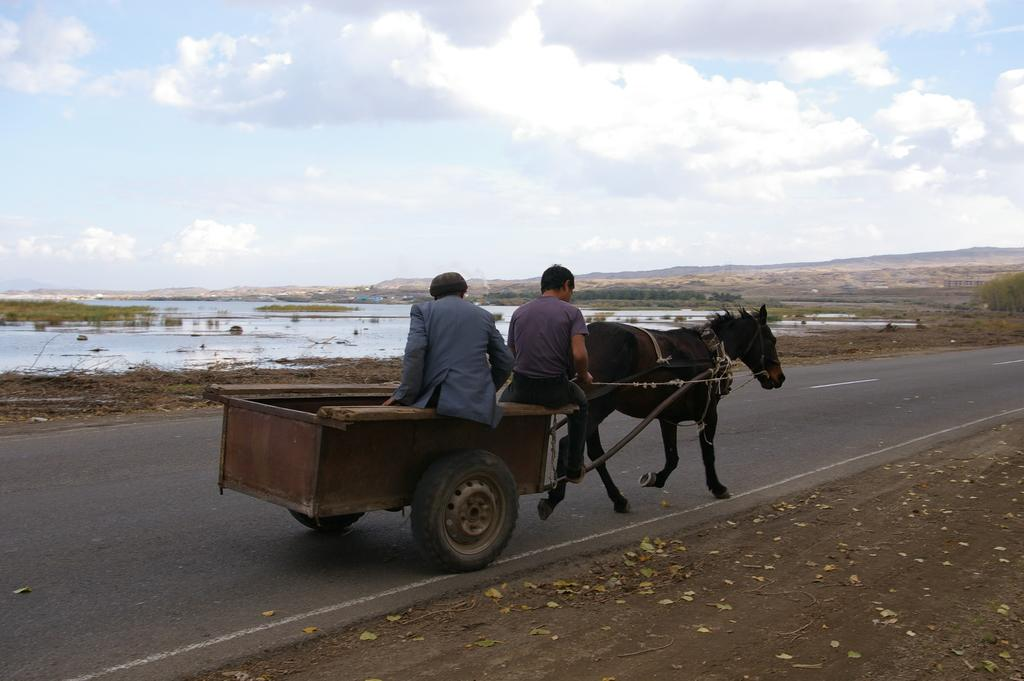How many people are in the image? There are two persons in the image. What are the persons doing in the image? The persons are riding a tango. What can be seen in the background of the image? There is a river and a mountain in the background of the image. How is the sky depicted in the image? The sky is cloudy at the top of the image. Can you see any letters on the tango that the persons are riding? There are no letters visible on the tango in the image. How many grapes are being kicked by the persons in the image? There are no grapes present in the image, and the persons are not kicking anything. 